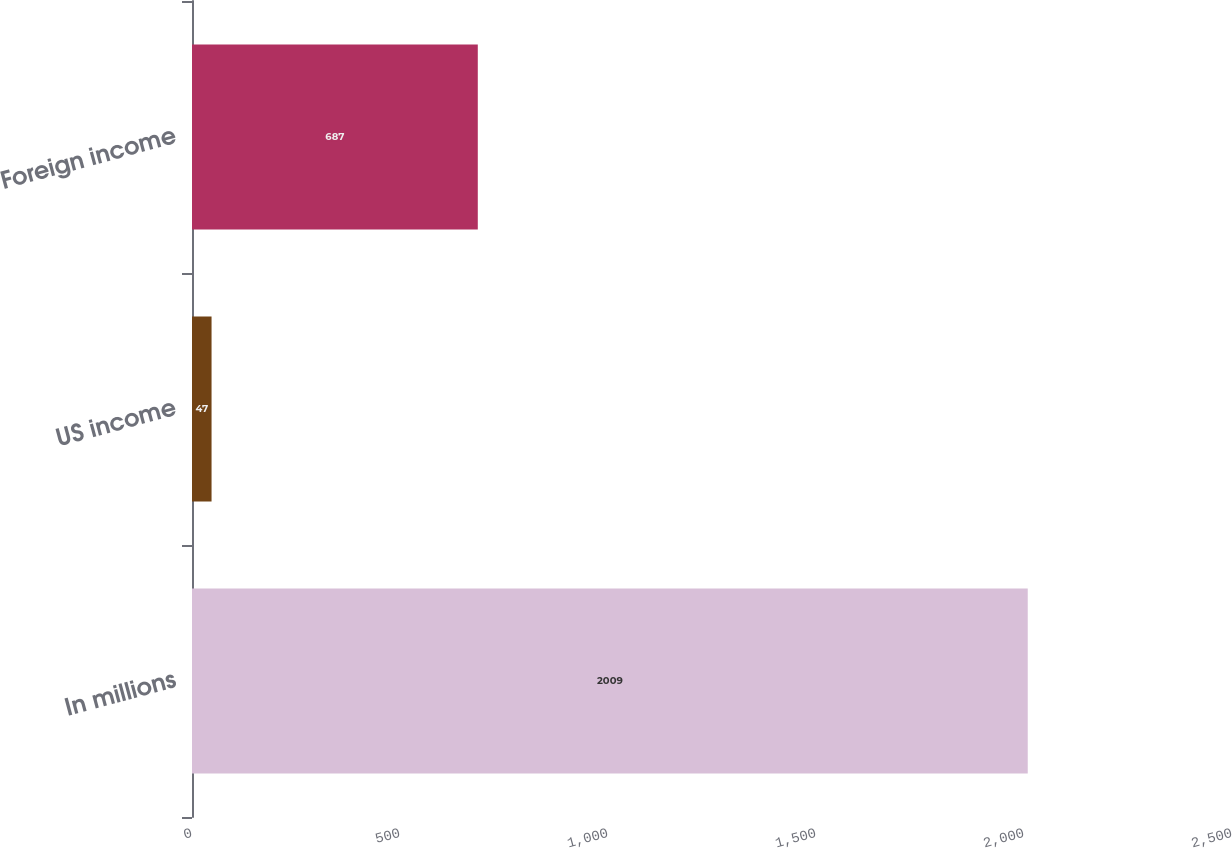<chart> <loc_0><loc_0><loc_500><loc_500><bar_chart><fcel>In millions<fcel>US income<fcel>Foreign income<nl><fcel>2009<fcel>47<fcel>687<nl></chart> 